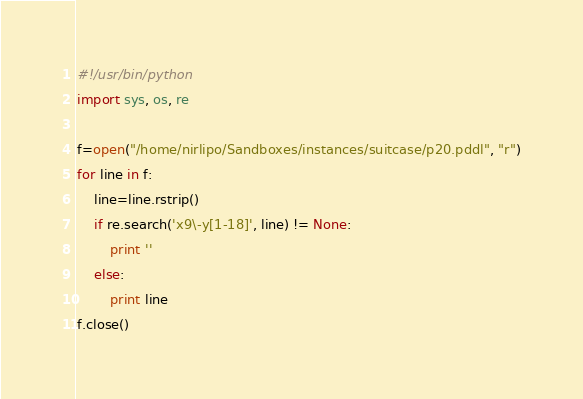Convert code to text. <code><loc_0><loc_0><loc_500><loc_500><_Python_>#!/usr/bin/python
import sys, os, re

f=open("/home/nirlipo/Sandboxes/instances/suitcase/p20.pddl", "r")
for line in f:
	line=line.rstrip()
	if re.search('x9\-y[1-18]', line) != None:
		print ''
	else:
		print line
f.close()
</code> 